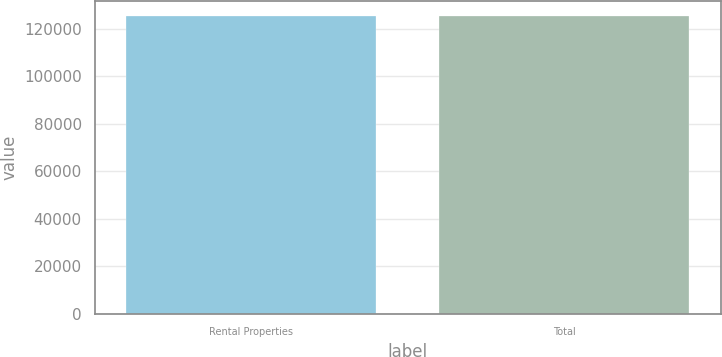Convert chart. <chart><loc_0><loc_0><loc_500><loc_500><bar_chart><fcel>Rental Properties<fcel>Total<nl><fcel>125250<fcel>125250<nl></chart> 